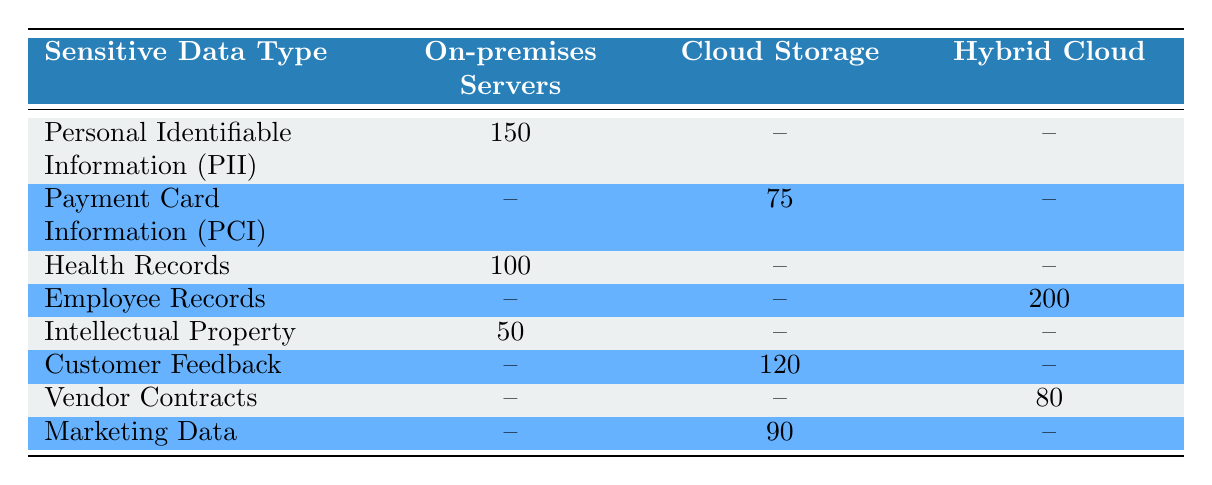What is the total count of Personal Identifiable Information collected? Looking at the row for Personal Identifiable Information, the count under On-premises Servers is 150. There are no additional counts for other storage locations. Therefore, the total count is simply 150.
Answer: 150 Which type of sensitive data is stored the most in Hybrid Cloud? The Hybrid Cloud section of the table shows only one value: Employee Records with a count of 200. Therefore, Employee Records is the only and highest type of sensitive data in that category.
Answer: Employee Records Is there any sensitive data related to Payment Card Information stored on-premises? In the table, Payment Card Information is only listed under Cloud Storage, with no counts in the On-premises Servers section. Hence, it can be confirmed that there is no sensitive data related to Payment Card Information stored on-premises.
Answer: No What is the total amount of sensitive data stored in Cloud Storage? In Cloud Storage, we have three types of data: Payment Card Information (75), Customer Feedback (120), and Marketing Data (90). Adding these amounts gives us 75 + 120 + 90 = 285. Therefore, the total count of sensitive data in Cloud Storage is 285.
Answer: 285 Are there more health records or intellectual property stored on-premises? For health records, the count is 100 and for intellectual property, the count is 50. Comparing these two values, health records (100) are greater than intellectual property (50). Therefore, more health records are stored on-premises.
Answer: Yes, more health records What is the average number of sensitive data items stored in On-premises Servers? We have three types of sensitive data stored in On-premises Servers: Personal Identifiable Information (150), Health Records (100), and Intellectual Property (50). Adding these gives us 150 + 100 + 50 = 300. The average is obtained by dividing by the number of data types, which is 3, giving 300 / 3 = 100.
Answer: 100 Which storage location has the lowest count of sensitive data? Upon examination of the counts for each storage location, only On-premises Servers (300), Cloud Storage (285), and Hybrid Cloud (280) are available. The Hybrid Cloud has the lowest count with 280.
Answer: Hybrid Cloud How many more Customer Feedback records are there than Payment Card Information records? The count for Customer Feedback is 120, whereas the count for Payment Card Information is 75. Subtracting the latter from the former gives us 120 - 75 = 45, which indicates there are 45 more Customer Feedback records.
Answer: 45 more What types of sensitive data are stored on-premises servers? Referring to the On-premises Servers column, I can see Personal Identifiable Information (150), Health Records (100), and Intellectual Property (50) are the three types of sensitive data stored there.
Answer: PII, Health Records, Intellectual Property 